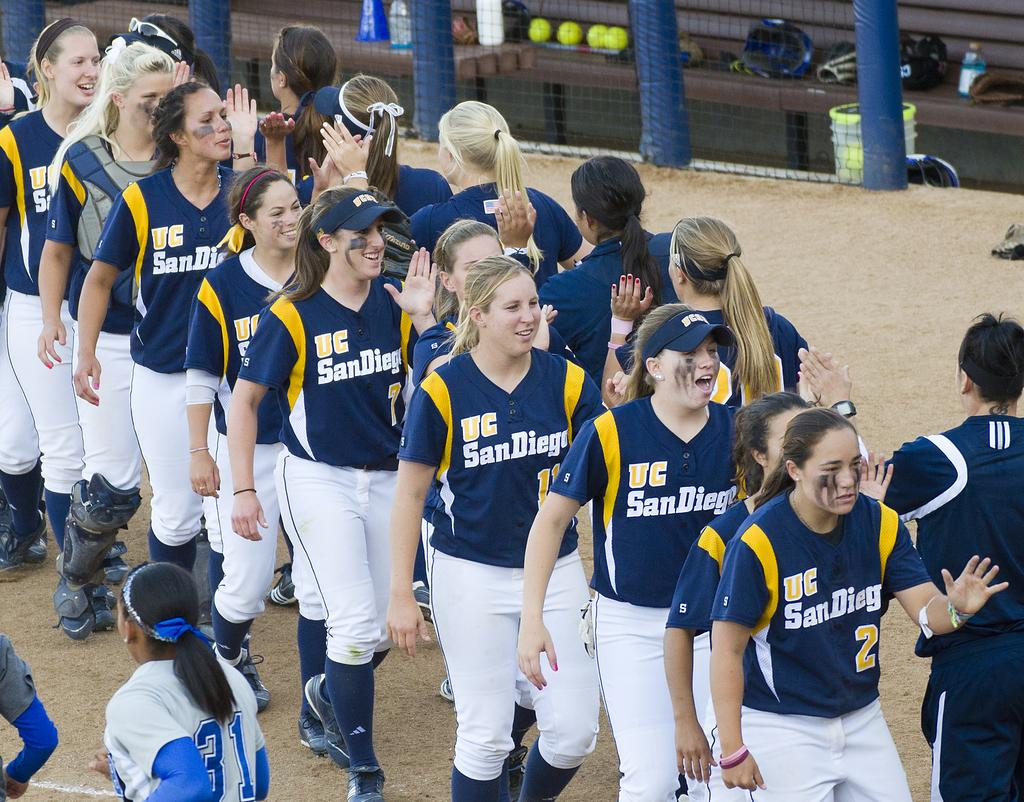<image>
Share a concise interpretation of the image provided. Members of UC San Diego's softball team line up to high five their opposing team. 